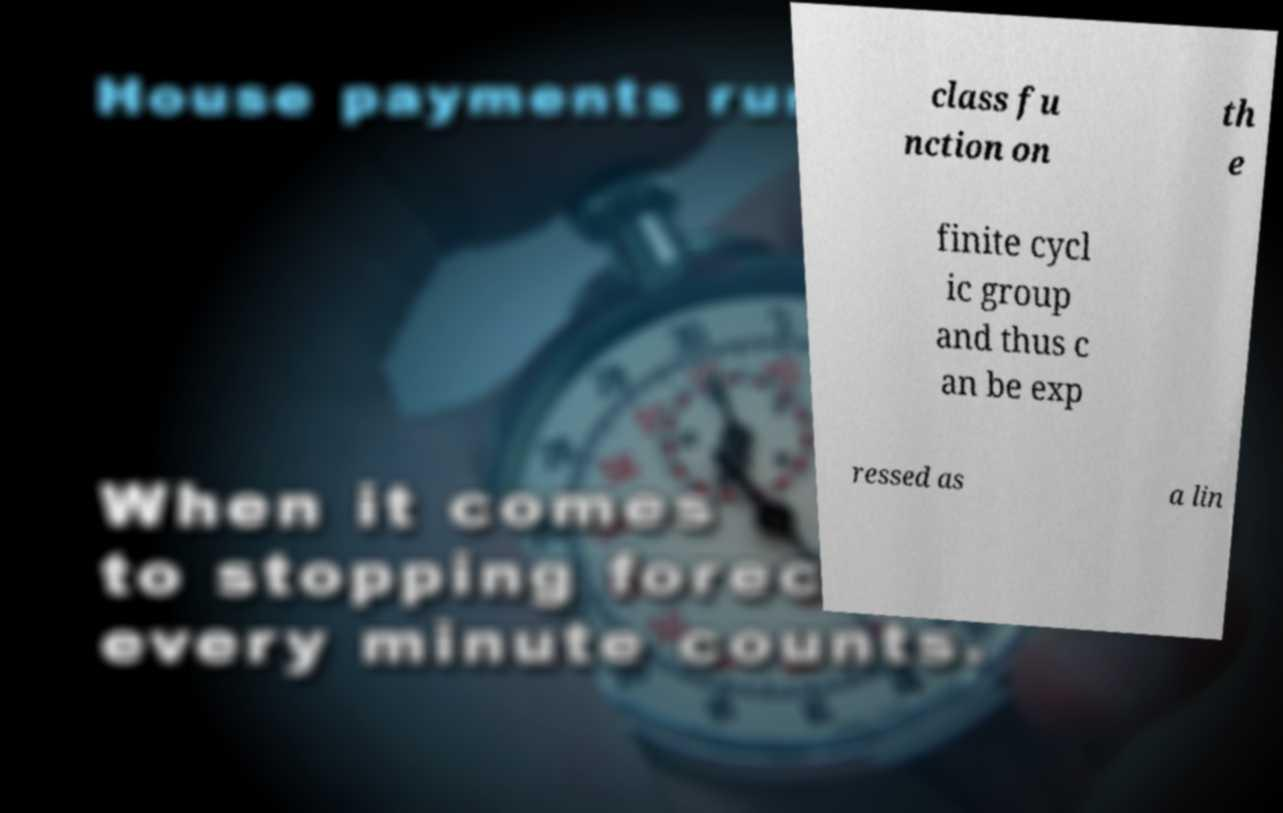Please read and relay the text visible in this image. What does it say? class fu nction on th e finite cycl ic group and thus c an be exp ressed as a lin 